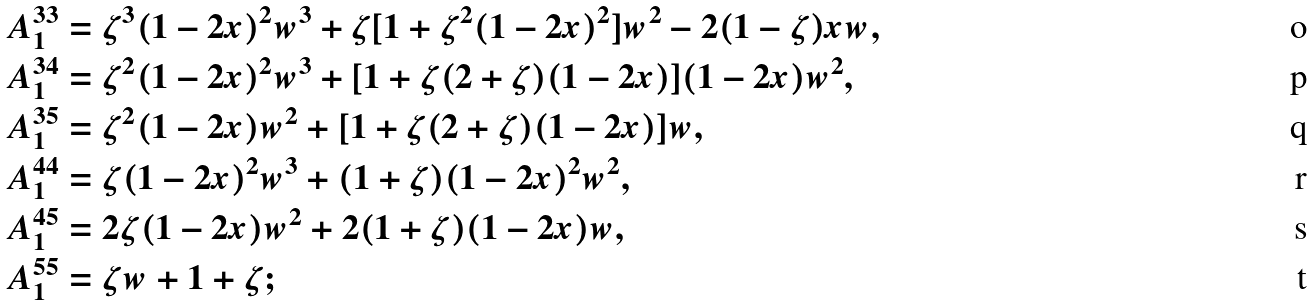Convert formula to latex. <formula><loc_0><loc_0><loc_500><loc_500>A ^ { 3 3 } _ { 1 } & = \zeta ^ { 3 } ( 1 - 2 x ) ^ { 2 } w ^ { 3 } + \zeta [ 1 + \zeta ^ { 2 } ( 1 - 2 x ) ^ { 2 } ] w ^ { 2 } - 2 ( 1 - \zeta ) x w , \\ A ^ { 3 4 } _ { 1 } & = \zeta ^ { 2 } ( 1 - 2 x ) ^ { 2 } w ^ { 3 } + [ 1 + \zeta ( 2 + \zeta ) ( 1 - 2 x ) ] ( 1 - 2 x ) w ^ { 2 } , \\ A ^ { 3 5 } _ { 1 } & = \zeta ^ { 2 } ( 1 - 2 x ) w ^ { 2 } + [ 1 + \zeta ( 2 + \zeta ) ( 1 - 2 x ) ] w , \\ A ^ { 4 4 } _ { 1 } & = \zeta ( 1 - 2 x ) ^ { 2 } w ^ { 3 } + ( 1 + \zeta ) ( 1 - 2 x ) ^ { 2 } w ^ { 2 } , \\ A ^ { 4 5 } _ { 1 } & = 2 \zeta ( 1 - 2 x ) w ^ { 2 } + 2 ( 1 + \zeta ) ( 1 - 2 x ) w , \\ A ^ { 5 5 } _ { 1 } & = \zeta w + 1 + \zeta ;</formula> 